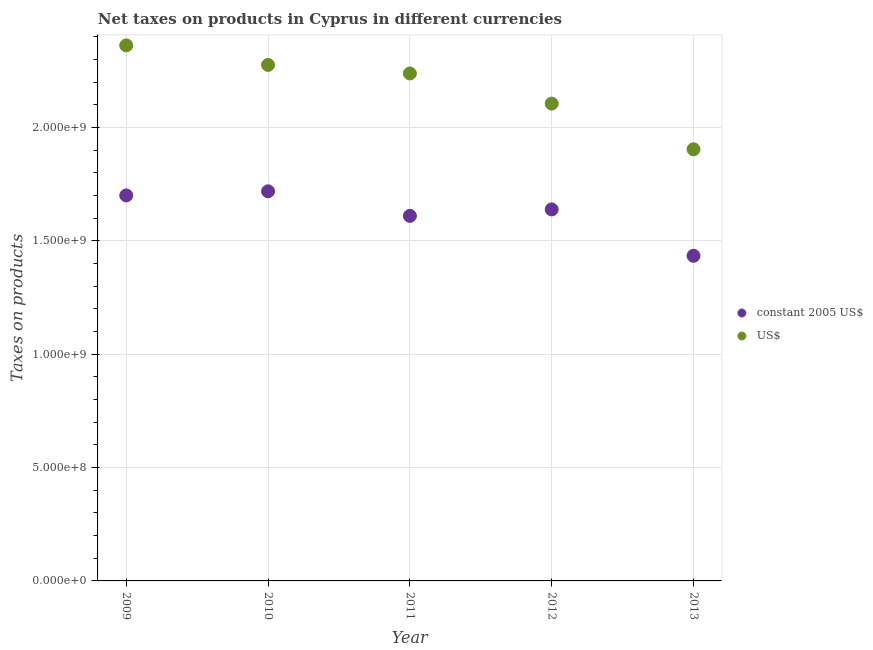How many different coloured dotlines are there?
Make the answer very short. 2. Is the number of dotlines equal to the number of legend labels?
Ensure brevity in your answer.  Yes. What is the net taxes in us$ in 2010?
Keep it short and to the point. 2.28e+09. Across all years, what is the maximum net taxes in constant 2005 us$?
Provide a succinct answer. 1.72e+09. Across all years, what is the minimum net taxes in us$?
Ensure brevity in your answer.  1.90e+09. In which year was the net taxes in constant 2005 us$ maximum?
Offer a very short reply. 2010. In which year was the net taxes in us$ minimum?
Provide a short and direct response. 2013. What is the total net taxes in us$ in the graph?
Your answer should be compact. 1.09e+1. What is the difference between the net taxes in us$ in 2009 and that in 2013?
Your response must be concise. 4.58e+08. What is the difference between the net taxes in us$ in 2011 and the net taxes in constant 2005 us$ in 2013?
Your response must be concise. 8.04e+08. What is the average net taxes in us$ per year?
Offer a very short reply. 2.18e+09. In the year 2010, what is the difference between the net taxes in constant 2005 us$ and net taxes in us$?
Provide a short and direct response. -5.57e+08. What is the ratio of the net taxes in constant 2005 us$ in 2010 to that in 2013?
Provide a short and direct response. 1.2. Is the net taxes in us$ in 2009 less than that in 2010?
Your answer should be very brief. No. What is the difference between the highest and the second highest net taxes in constant 2005 us$?
Provide a short and direct response. 1.81e+07. What is the difference between the highest and the lowest net taxes in constant 2005 us$?
Give a very brief answer. 2.84e+08. How many dotlines are there?
Ensure brevity in your answer.  2. What is the difference between two consecutive major ticks on the Y-axis?
Provide a short and direct response. 5.00e+08. Does the graph contain grids?
Provide a succinct answer. Yes. Where does the legend appear in the graph?
Your response must be concise. Center right. How many legend labels are there?
Ensure brevity in your answer.  2. What is the title of the graph?
Provide a succinct answer. Net taxes on products in Cyprus in different currencies. Does "International Tourists" appear as one of the legend labels in the graph?
Offer a very short reply. No. What is the label or title of the Y-axis?
Keep it short and to the point. Taxes on products. What is the Taxes on products in constant 2005 US$ in 2009?
Provide a succinct answer. 1.70e+09. What is the Taxes on products in US$ in 2009?
Your response must be concise. 2.36e+09. What is the Taxes on products of constant 2005 US$ in 2010?
Give a very brief answer. 1.72e+09. What is the Taxes on products in US$ in 2010?
Provide a short and direct response. 2.28e+09. What is the Taxes on products in constant 2005 US$ in 2011?
Your answer should be compact. 1.61e+09. What is the Taxes on products of US$ in 2011?
Your answer should be compact. 2.24e+09. What is the Taxes on products of constant 2005 US$ in 2012?
Offer a very short reply. 1.64e+09. What is the Taxes on products in US$ in 2012?
Provide a short and direct response. 2.11e+09. What is the Taxes on products of constant 2005 US$ in 2013?
Keep it short and to the point. 1.43e+09. What is the Taxes on products in US$ in 2013?
Provide a short and direct response. 1.90e+09. Across all years, what is the maximum Taxes on products of constant 2005 US$?
Your answer should be very brief. 1.72e+09. Across all years, what is the maximum Taxes on products in US$?
Offer a terse response. 2.36e+09. Across all years, what is the minimum Taxes on products in constant 2005 US$?
Ensure brevity in your answer.  1.43e+09. Across all years, what is the minimum Taxes on products in US$?
Your answer should be very brief. 1.90e+09. What is the total Taxes on products in constant 2005 US$ in the graph?
Offer a terse response. 8.10e+09. What is the total Taxes on products of US$ in the graph?
Offer a terse response. 1.09e+1. What is the difference between the Taxes on products of constant 2005 US$ in 2009 and that in 2010?
Your response must be concise. -1.81e+07. What is the difference between the Taxes on products in US$ in 2009 and that in 2010?
Make the answer very short. 8.61e+07. What is the difference between the Taxes on products of constant 2005 US$ in 2009 and that in 2011?
Your response must be concise. 9.02e+07. What is the difference between the Taxes on products of US$ in 2009 and that in 2011?
Make the answer very short. 1.24e+08. What is the difference between the Taxes on products of constant 2005 US$ in 2009 and that in 2012?
Give a very brief answer. 6.17e+07. What is the difference between the Taxes on products in US$ in 2009 and that in 2012?
Your response must be concise. 2.57e+08. What is the difference between the Taxes on products in constant 2005 US$ in 2009 and that in 2013?
Offer a very short reply. 2.66e+08. What is the difference between the Taxes on products of US$ in 2009 and that in 2013?
Your answer should be compact. 4.58e+08. What is the difference between the Taxes on products in constant 2005 US$ in 2010 and that in 2011?
Offer a very short reply. 1.08e+08. What is the difference between the Taxes on products in US$ in 2010 and that in 2011?
Provide a succinct answer. 3.77e+07. What is the difference between the Taxes on products of constant 2005 US$ in 2010 and that in 2012?
Provide a succinct answer. 7.99e+07. What is the difference between the Taxes on products of US$ in 2010 and that in 2012?
Offer a very short reply. 1.71e+08. What is the difference between the Taxes on products of constant 2005 US$ in 2010 and that in 2013?
Offer a very short reply. 2.84e+08. What is the difference between the Taxes on products of US$ in 2010 and that in 2013?
Your response must be concise. 3.72e+08. What is the difference between the Taxes on products of constant 2005 US$ in 2011 and that in 2012?
Keep it short and to the point. -2.85e+07. What is the difference between the Taxes on products of US$ in 2011 and that in 2012?
Your response must be concise. 1.33e+08. What is the difference between the Taxes on products in constant 2005 US$ in 2011 and that in 2013?
Your answer should be very brief. 1.76e+08. What is the difference between the Taxes on products in US$ in 2011 and that in 2013?
Provide a succinct answer. 3.34e+08. What is the difference between the Taxes on products of constant 2005 US$ in 2012 and that in 2013?
Your response must be concise. 2.05e+08. What is the difference between the Taxes on products of US$ in 2012 and that in 2013?
Offer a very short reply. 2.01e+08. What is the difference between the Taxes on products in constant 2005 US$ in 2009 and the Taxes on products in US$ in 2010?
Your answer should be very brief. -5.76e+08. What is the difference between the Taxes on products in constant 2005 US$ in 2009 and the Taxes on products in US$ in 2011?
Offer a terse response. -5.38e+08. What is the difference between the Taxes on products in constant 2005 US$ in 2009 and the Taxes on products in US$ in 2012?
Make the answer very short. -4.05e+08. What is the difference between the Taxes on products of constant 2005 US$ in 2009 and the Taxes on products of US$ in 2013?
Make the answer very short. -2.04e+08. What is the difference between the Taxes on products of constant 2005 US$ in 2010 and the Taxes on products of US$ in 2011?
Offer a terse response. -5.20e+08. What is the difference between the Taxes on products in constant 2005 US$ in 2010 and the Taxes on products in US$ in 2012?
Ensure brevity in your answer.  -3.87e+08. What is the difference between the Taxes on products of constant 2005 US$ in 2010 and the Taxes on products of US$ in 2013?
Your answer should be very brief. -1.85e+08. What is the difference between the Taxes on products of constant 2005 US$ in 2011 and the Taxes on products of US$ in 2012?
Your response must be concise. -4.95e+08. What is the difference between the Taxes on products of constant 2005 US$ in 2011 and the Taxes on products of US$ in 2013?
Provide a succinct answer. -2.94e+08. What is the difference between the Taxes on products in constant 2005 US$ in 2012 and the Taxes on products in US$ in 2013?
Give a very brief answer. -2.65e+08. What is the average Taxes on products in constant 2005 US$ per year?
Provide a succinct answer. 1.62e+09. What is the average Taxes on products of US$ per year?
Your response must be concise. 2.18e+09. In the year 2009, what is the difference between the Taxes on products in constant 2005 US$ and Taxes on products in US$?
Your answer should be very brief. -6.62e+08. In the year 2010, what is the difference between the Taxes on products in constant 2005 US$ and Taxes on products in US$?
Offer a terse response. -5.57e+08. In the year 2011, what is the difference between the Taxes on products in constant 2005 US$ and Taxes on products in US$?
Provide a short and direct response. -6.28e+08. In the year 2012, what is the difference between the Taxes on products in constant 2005 US$ and Taxes on products in US$?
Provide a short and direct response. -4.67e+08. In the year 2013, what is the difference between the Taxes on products in constant 2005 US$ and Taxes on products in US$?
Offer a terse response. -4.70e+08. What is the ratio of the Taxes on products of constant 2005 US$ in 2009 to that in 2010?
Provide a succinct answer. 0.99. What is the ratio of the Taxes on products in US$ in 2009 to that in 2010?
Your response must be concise. 1.04. What is the ratio of the Taxes on products in constant 2005 US$ in 2009 to that in 2011?
Your answer should be very brief. 1.06. What is the ratio of the Taxes on products of US$ in 2009 to that in 2011?
Offer a very short reply. 1.06. What is the ratio of the Taxes on products in constant 2005 US$ in 2009 to that in 2012?
Ensure brevity in your answer.  1.04. What is the ratio of the Taxes on products of US$ in 2009 to that in 2012?
Give a very brief answer. 1.12. What is the ratio of the Taxes on products of constant 2005 US$ in 2009 to that in 2013?
Your answer should be very brief. 1.19. What is the ratio of the Taxes on products in US$ in 2009 to that in 2013?
Give a very brief answer. 1.24. What is the ratio of the Taxes on products in constant 2005 US$ in 2010 to that in 2011?
Offer a terse response. 1.07. What is the ratio of the Taxes on products in US$ in 2010 to that in 2011?
Make the answer very short. 1.02. What is the ratio of the Taxes on products in constant 2005 US$ in 2010 to that in 2012?
Ensure brevity in your answer.  1.05. What is the ratio of the Taxes on products of US$ in 2010 to that in 2012?
Ensure brevity in your answer.  1.08. What is the ratio of the Taxes on products in constant 2005 US$ in 2010 to that in 2013?
Your answer should be compact. 1.2. What is the ratio of the Taxes on products in US$ in 2010 to that in 2013?
Provide a succinct answer. 1.2. What is the ratio of the Taxes on products in constant 2005 US$ in 2011 to that in 2012?
Provide a short and direct response. 0.98. What is the ratio of the Taxes on products of US$ in 2011 to that in 2012?
Keep it short and to the point. 1.06. What is the ratio of the Taxes on products of constant 2005 US$ in 2011 to that in 2013?
Give a very brief answer. 1.12. What is the ratio of the Taxes on products of US$ in 2011 to that in 2013?
Your answer should be very brief. 1.18. What is the ratio of the Taxes on products of constant 2005 US$ in 2012 to that in 2013?
Make the answer very short. 1.14. What is the ratio of the Taxes on products in US$ in 2012 to that in 2013?
Provide a succinct answer. 1.11. What is the difference between the highest and the second highest Taxes on products of constant 2005 US$?
Ensure brevity in your answer.  1.81e+07. What is the difference between the highest and the second highest Taxes on products in US$?
Make the answer very short. 8.61e+07. What is the difference between the highest and the lowest Taxes on products in constant 2005 US$?
Your answer should be compact. 2.84e+08. What is the difference between the highest and the lowest Taxes on products of US$?
Provide a short and direct response. 4.58e+08. 